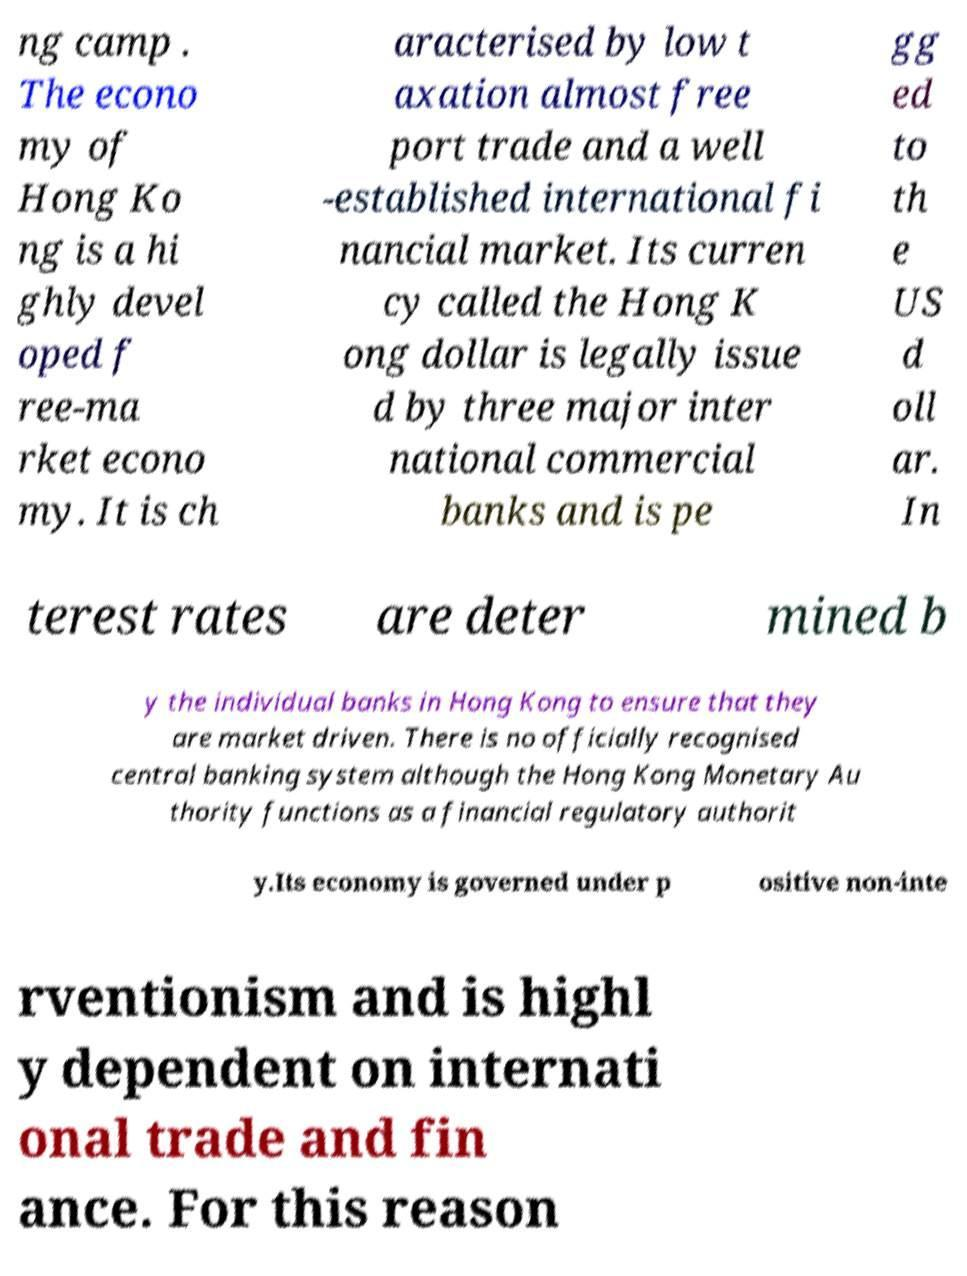Please read and relay the text visible in this image. What does it say? ng camp . The econo my of Hong Ko ng is a hi ghly devel oped f ree-ma rket econo my. It is ch aracterised by low t axation almost free port trade and a well -established international fi nancial market. Its curren cy called the Hong K ong dollar is legally issue d by three major inter national commercial banks and is pe gg ed to th e US d oll ar. In terest rates are deter mined b y the individual banks in Hong Kong to ensure that they are market driven. There is no officially recognised central banking system although the Hong Kong Monetary Au thority functions as a financial regulatory authorit y.Its economy is governed under p ositive non-inte rventionism and is highl y dependent on internati onal trade and fin ance. For this reason 